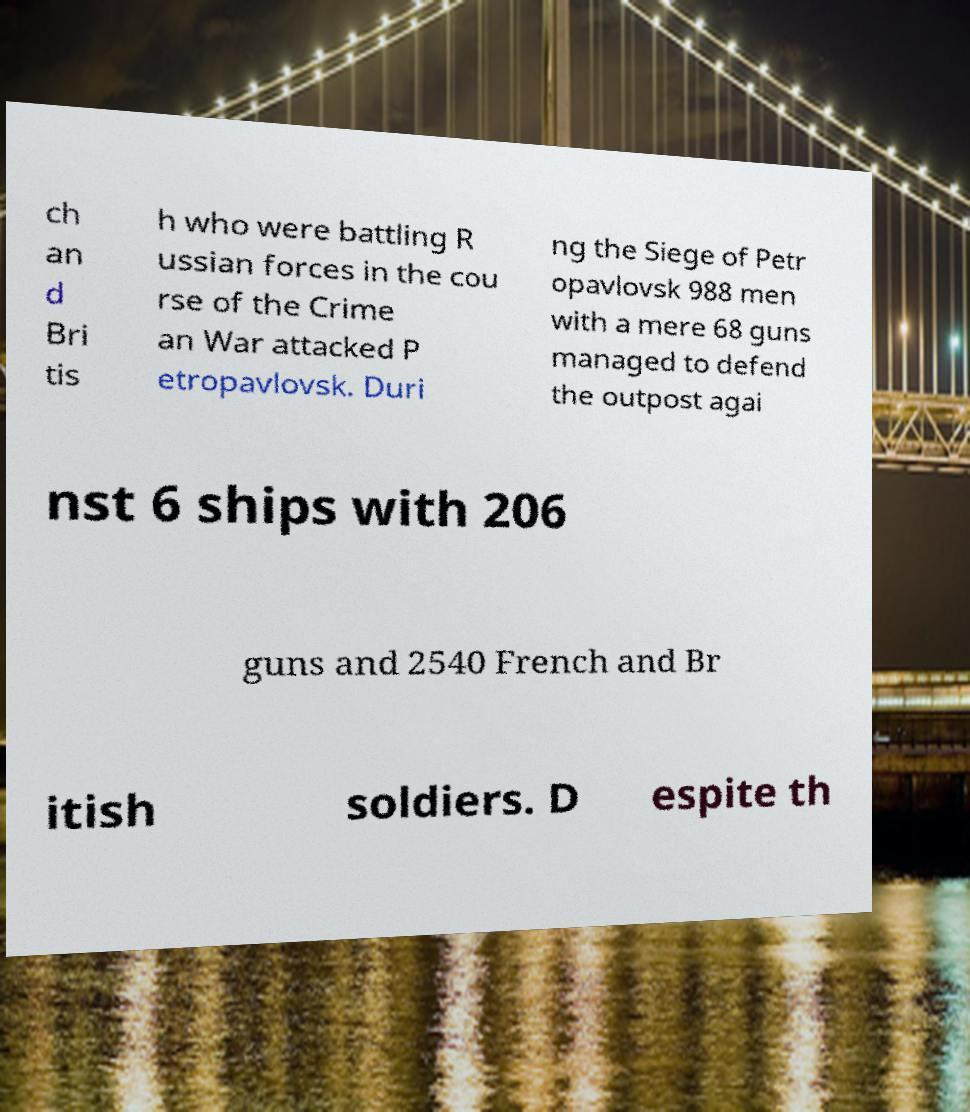Can you accurately transcribe the text from the provided image for me? ch an d Bri tis h who were battling R ussian forces in the cou rse of the Crime an War attacked P etropavlovsk. Duri ng the Siege of Petr opavlovsk 988 men with a mere 68 guns managed to defend the outpost agai nst 6 ships with 206 guns and 2540 French and Br itish soldiers. D espite th 